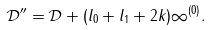Convert formula to latex. <formula><loc_0><loc_0><loc_500><loc_500>\mathcal { D } ^ { \prime \prime } = \mathcal { D } + ( l _ { 0 } + l _ { 1 } + 2 k ) \infty ^ { ( 0 ) } .</formula> 